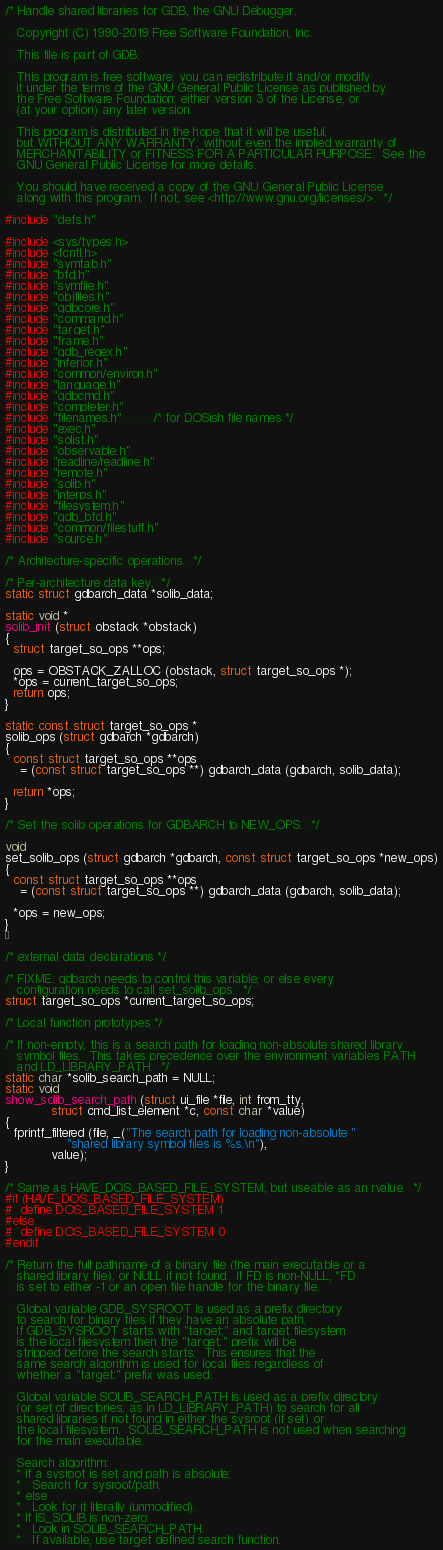Convert code to text. <code><loc_0><loc_0><loc_500><loc_500><_C_>/* Handle shared libraries for GDB, the GNU Debugger.

   Copyright (C) 1990-2019 Free Software Foundation, Inc.

   This file is part of GDB.

   This program is free software; you can redistribute it and/or modify
   it under the terms of the GNU General Public License as published by
   the Free Software Foundation; either version 3 of the License, or
   (at your option) any later version.

   This program is distributed in the hope that it will be useful,
   but WITHOUT ANY WARRANTY; without even the implied warranty of
   MERCHANTABILITY or FITNESS FOR A PARTICULAR PURPOSE.  See the
   GNU General Public License for more details.

   You should have received a copy of the GNU General Public License
   along with this program.  If not, see <http://www.gnu.org/licenses/>.  */

#include "defs.h"

#include <sys/types.h>
#include <fcntl.h>
#include "symtab.h"
#include "bfd.h"
#include "symfile.h"
#include "objfiles.h"
#include "gdbcore.h"
#include "command.h"
#include "target.h"
#include "frame.h"
#include "gdb_regex.h"
#include "inferior.h"
#include "common/environ.h"
#include "language.h"
#include "gdbcmd.h"
#include "completer.h"
#include "filenames.h"		/* for DOSish file names */
#include "exec.h"
#include "solist.h"
#include "observable.h"
#include "readline/readline.h"
#include "remote.h"
#include "solib.h"
#include "interps.h"
#include "filesystem.h"
#include "gdb_bfd.h"
#include "common/filestuff.h"
#include "source.h"

/* Architecture-specific operations.  */

/* Per-architecture data key.  */
static struct gdbarch_data *solib_data;

static void *
solib_init (struct obstack *obstack)
{
  struct target_so_ops **ops;

  ops = OBSTACK_ZALLOC (obstack, struct target_so_ops *);
  *ops = current_target_so_ops;
  return ops;
}

static const struct target_so_ops *
solib_ops (struct gdbarch *gdbarch)
{
  const struct target_so_ops **ops
    = (const struct target_so_ops **) gdbarch_data (gdbarch, solib_data);

  return *ops;
}

/* Set the solib operations for GDBARCH to NEW_OPS.  */

void
set_solib_ops (struct gdbarch *gdbarch, const struct target_so_ops *new_ops)
{
  const struct target_so_ops **ops
    = (const struct target_so_ops **) gdbarch_data (gdbarch, solib_data);

  *ops = new_ops;
}


/* external data declarations */

/* FIXME: gdbarch needs to control this variable, or else every
   configuration needs to call set_solib_ops.  */
struct target_so_ops *current_target_so_ops;

/* Local function prototypes */

/* If non-empty, this is a search path for loading non-absolute shared library
   symbol files.  This takes precedence over the environment variables PATH
   and LD_LIBRARY_PATH.  */
static char *solib_search_path = NULL;
static void
show_solib_search_path (struct ui_file *file, int from_tty,
			struct cmd_list_element *c, const char *value)
{
  fprintf_filtered (file, _("The search path for loading non-absolute "
			    "shared library symbol files is %s.\n"),
		    value);
}

/* Same as HAVE_DOS_BASED_FILE_SYSTEM, but useable as an rvalue.  */
#if (HAVE_DOS_BASED_FILE_SYSTEM)
#  define DOS_BASED_FILE_SYSTEM 1
#else
#  define DOS_BASED_FILE_SYSTEM 0
#endif

/* Return the full pathname of a binary file (the main executable or a
   shared library file), or NULL if not found.  If FD is non-NULL, *FD
   is set to either -1 or an open file handle for the binary file.

   Global variable GDB_SYSROOT is used as a prefix directory
   to search for binary files if they have an absolute path.
   If GDB_SYSROOT starts with "target:" and target filesystem
   is the local filesystem then the "target:" prefix will be
   stripped before the search starts.  This ensures that the
   same search algorithm is used for local files regardless of
   whether a "target:" prefix was used.

   Global variable SOLIB_SEARCH_PATH is used as a prefix directory
   (or set of directories, as in LD_LIBRARY_PATH) to search for all
   shared libraries if not found in either the sysroot (if set) or
   the local filesystem.  SOLIB_SEARCH_PATH is not used when searching
   for the main executable.

   Search algorithm:
   * If a sysroot is set and path is absolute:
   *   Search for sysroot/path.
   * else
   *   Look for it literally (unmodified).
   * If IS_SOLIB is non-zero:
   *   Look in SOLIB_SEARCH_PATH.
   *   If available, use target defined search function.</code> 